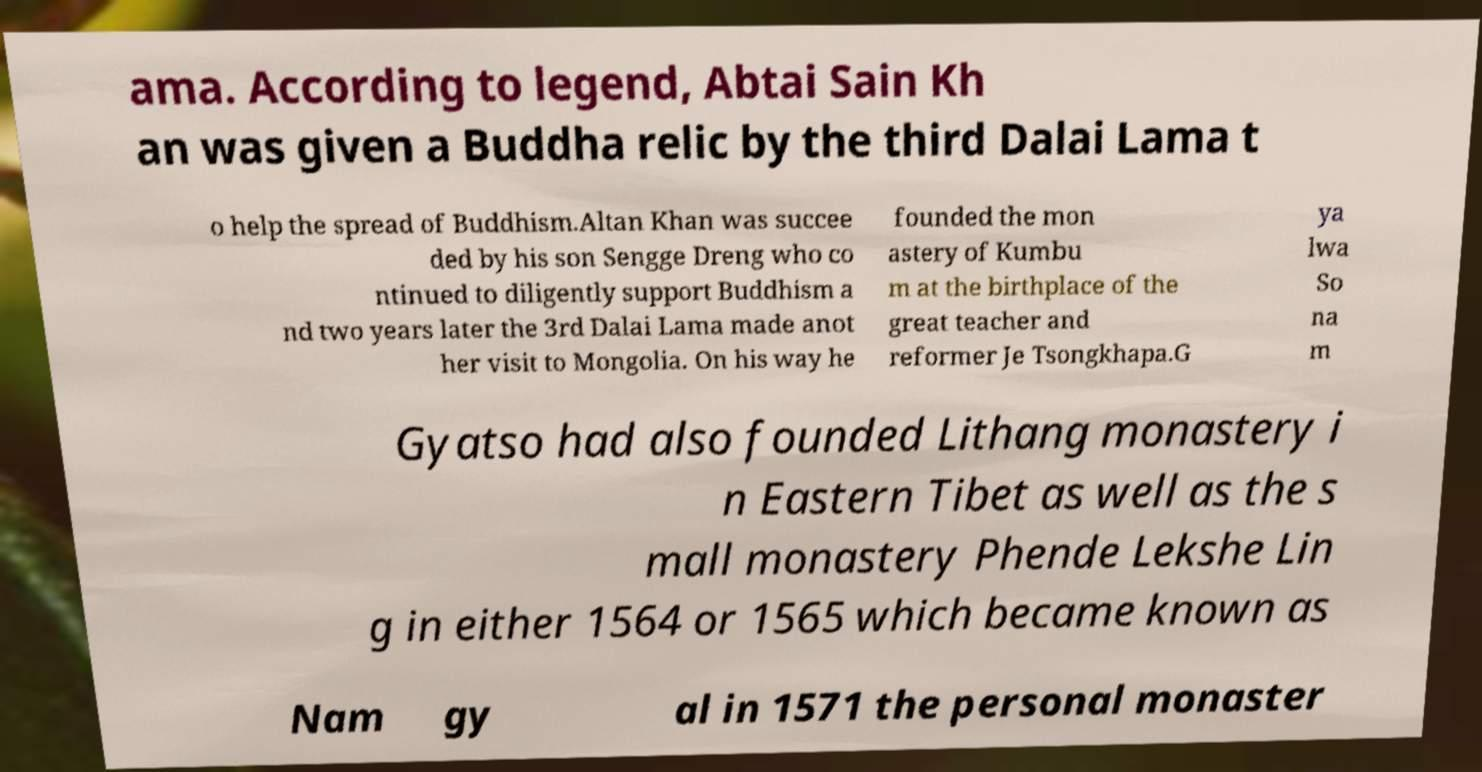Can you accurately transcribe the text from the provided image for me? ama. According to legend, Abtai Sain Kh an was given a Buddha relic by the third Dalai Lama t o help the spread of Buddhism.Altan Khan was succee ded by his son Sengge Dreng who co ntinued to diligently support Buddhism a nd two years later the 3rd Dalai Lama made anot her visit to Mongolia. On his way he founded the mon astery of Kumbu m at the birthplace of the great teacher and reformer Je Tsongkhapa.G ya lwa So na m Gyatso had also founded Lithang monastery i n Eastern Tibet as well as the s mall monastery Phende Lekshe Lin g in either 1564 or 1565 which became known as Nam gy al in 1571 the personal monaster 